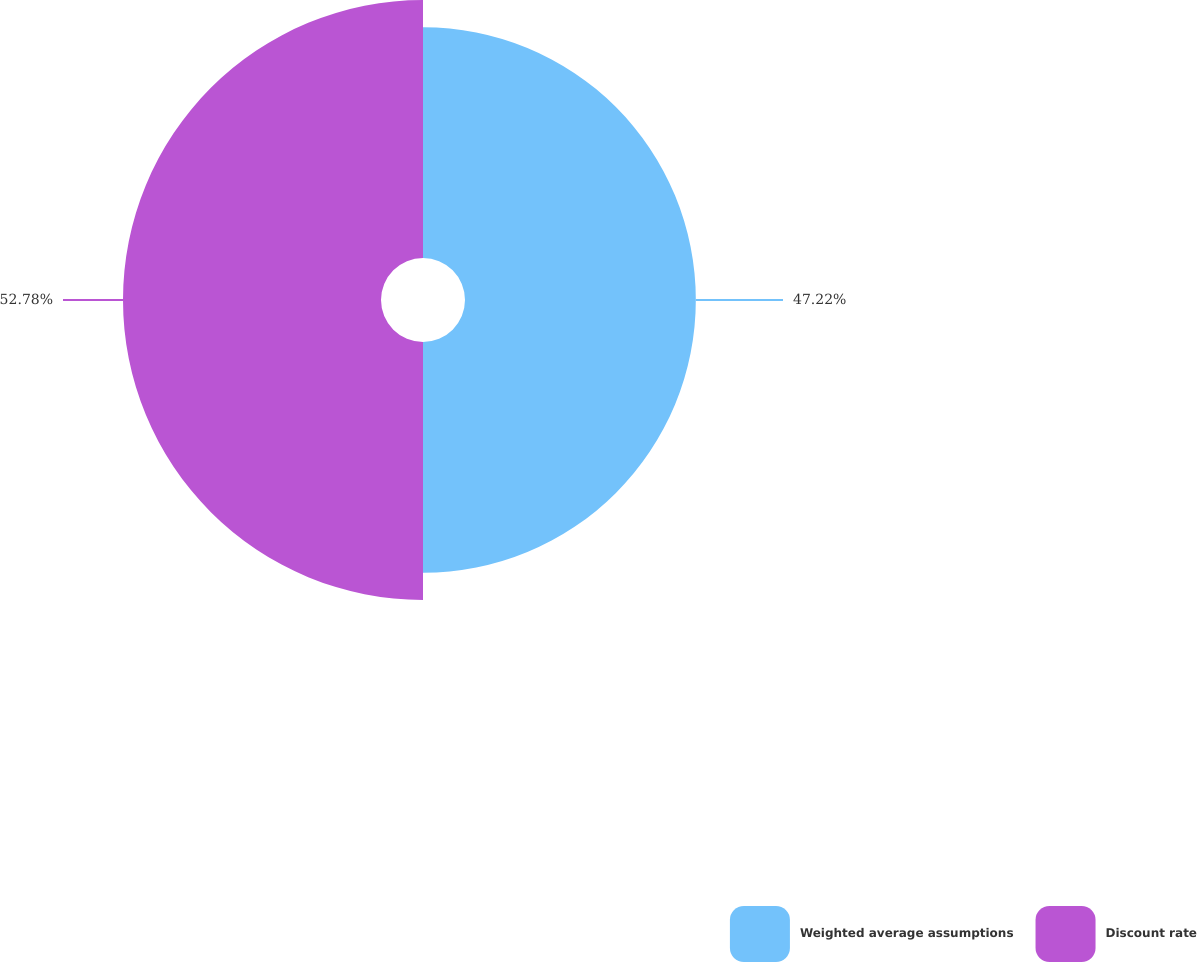Convert chart to OTSL. <chart><loc_0><loc_0><loc_500><loc_500><pie_chart><fcel>Weighted average assumptions<fcel>Discount rate<nl><fcel>47.22%<fcel>52.78%<nl></chart> 